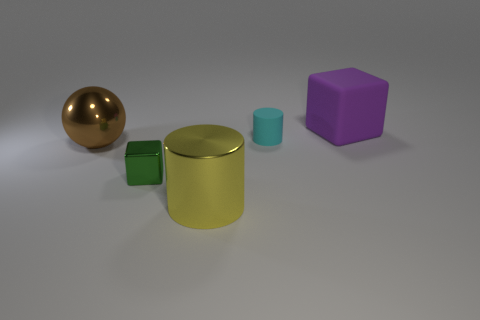What can you infer about the texture of the objects? The brown sphere possesses a reflective and shiny texture, which implies it is likely made out of a material like polished metal. The other objects, the cubes and the cylinders, have a matte finish suggesting they could be made of plastic or a similar non-reflective material. 